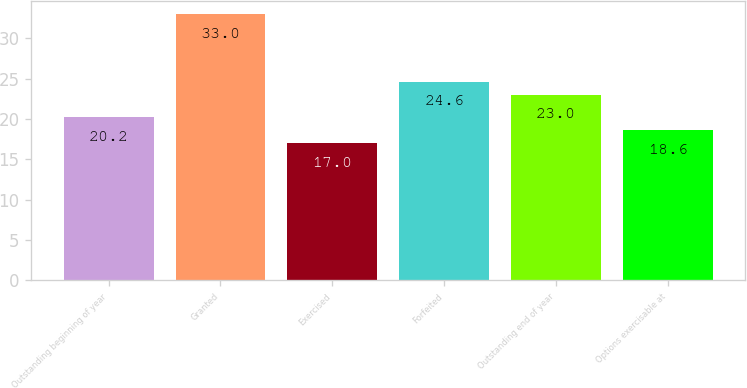<chart> <loc_0><loc_0><loc_500><loc_500><bar_chart><fcel>Outstanding beginning of year<fcel>Granted<fcel>Exercised<fcel>Forfeited<fcel>Outstanding end of year<fcel>Options exercisable at<nl><fcel>20.2<fcel>33<fcel>17<fcel>24.6<fcel>23<fcel>18.6<nl></chart> 